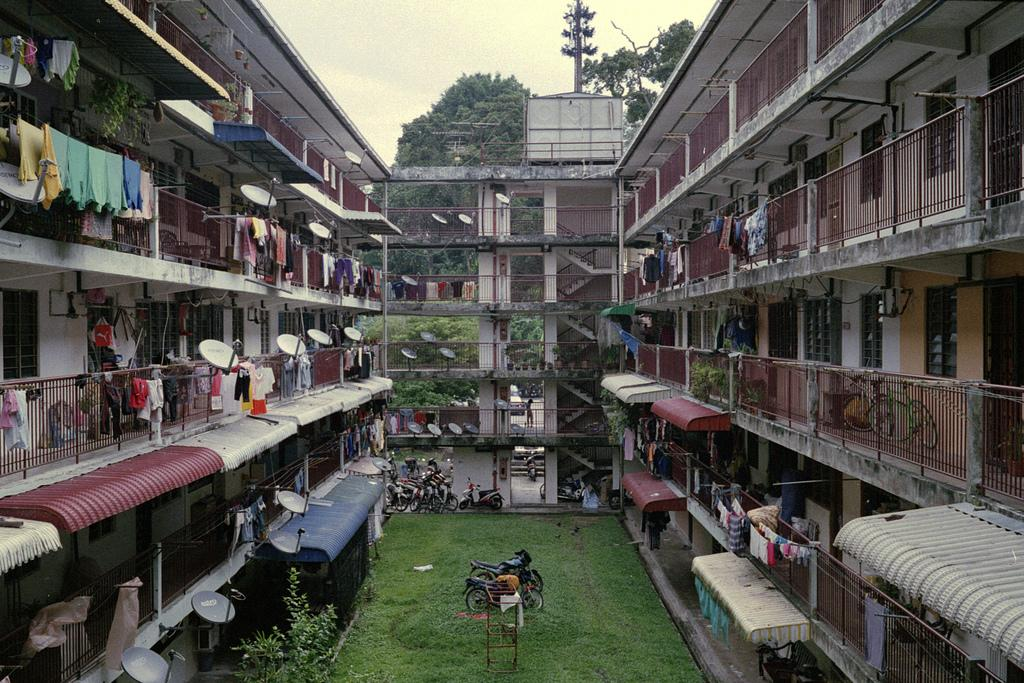What type of vegetation can be seen in the image? There is grass in the image, as well as plants and trees in the background. What structures are present in the image? There is a stand, railings, a dish antenna, a building, and a current pole in the image. What objects can be seen in the image? There are bikes, vehicles, and clothes in the image. What is visible in the background of the image? There are trees and sky visible in the background of the image. What time of day is the judge depicted in the image? There is no judge present in the image, so it is not possible to determine the time of day. What type of sheet is covering the bikes in the image? There are no sheets covering the bikes in the image; they are visible and not obstructed. 